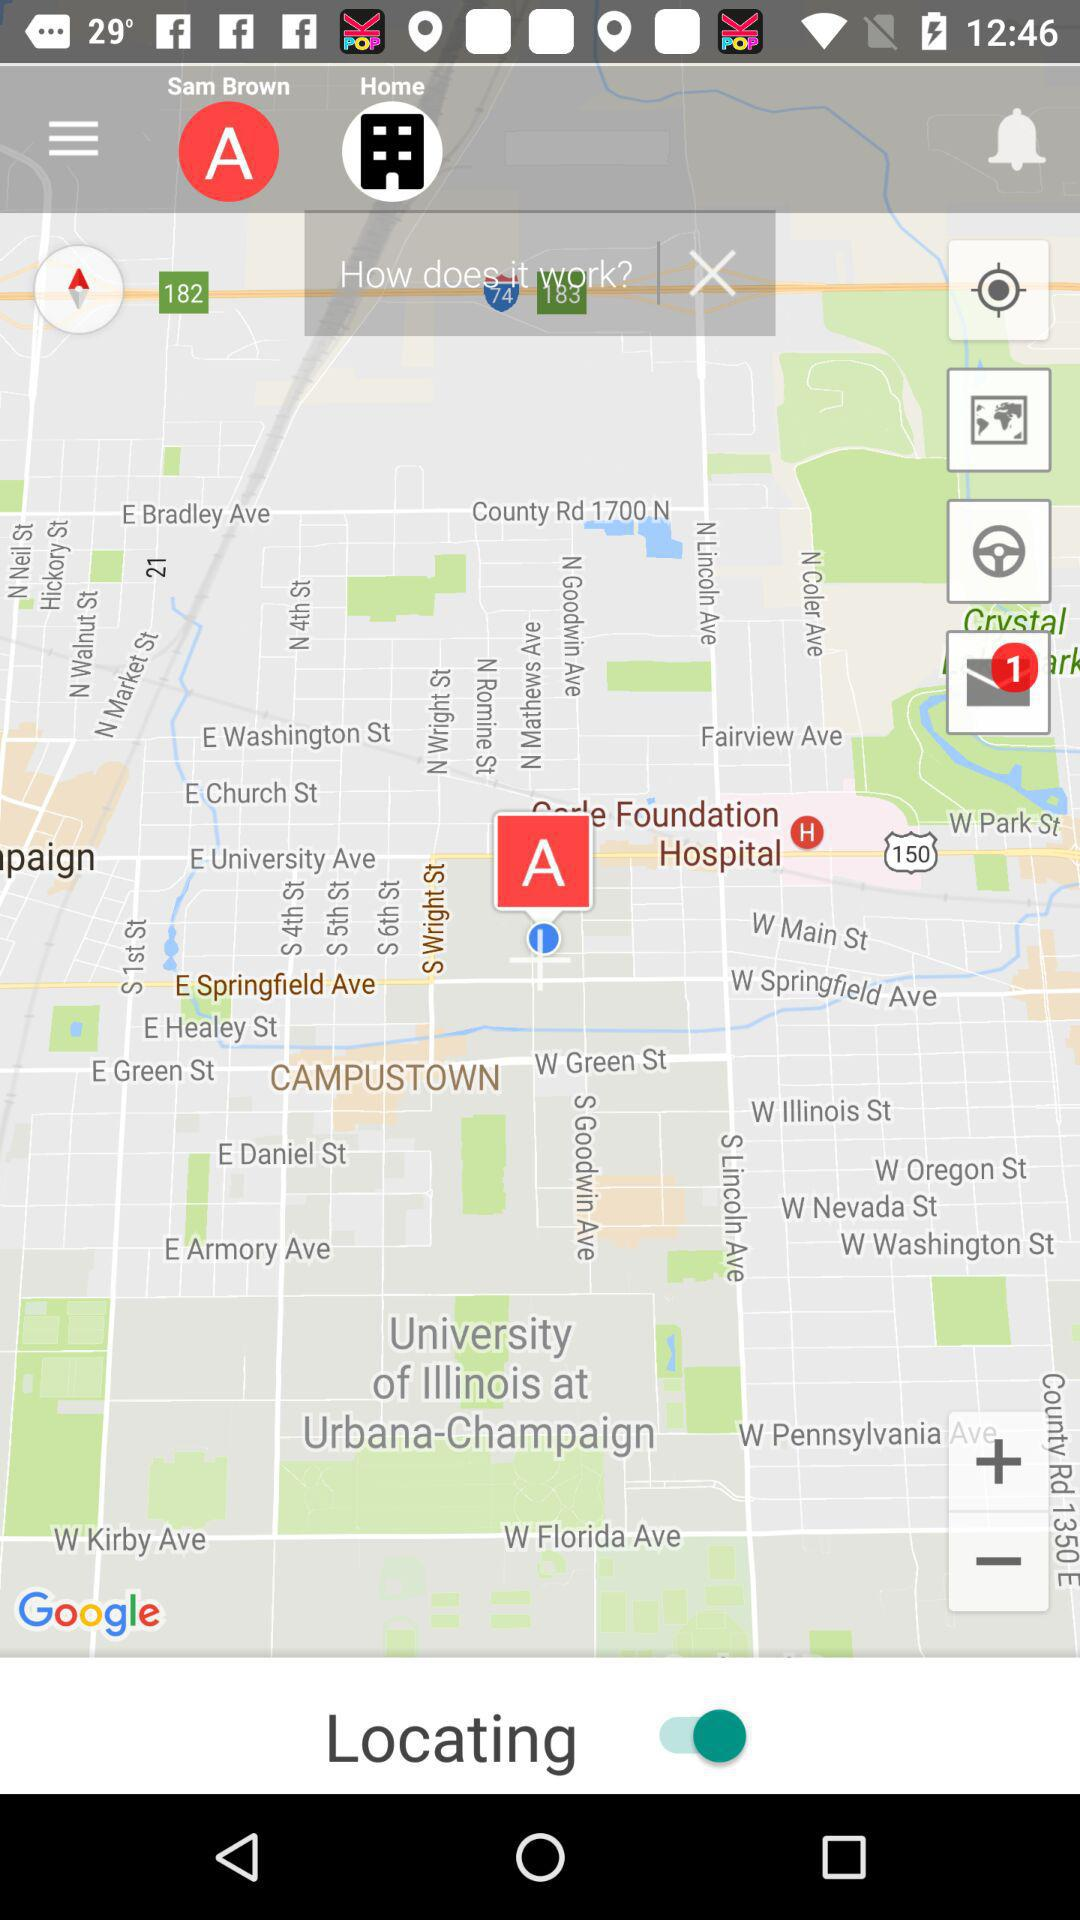What is the user name? The user name is Sam Brown. 